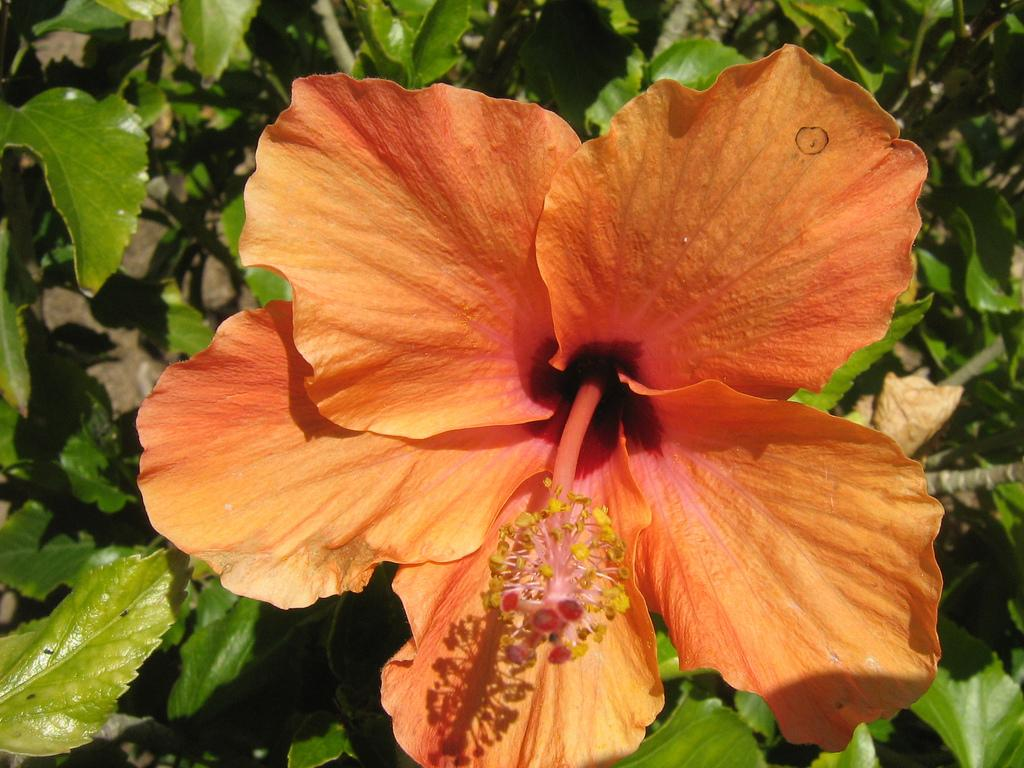What celestial bodies are depicted in the image? There are planets in the image. What type of plant is present in the image? There is a flower in the image. What type of monkey can be seen playing a guitar in the image? There is no monkey or guitar present in the image; it features planets and a flower. 